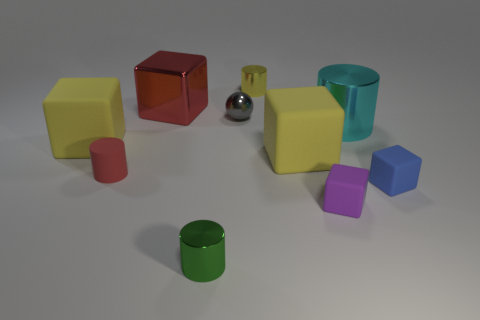Subtract all big metallic blocks. How many blocks are left? 4 Subtract all blue blocks. How many blocks are left? 4 Subtract all green blocks. Subtract all green cylinders. How many blocks are left? 5 Subtract all spheres. How many objects are left? 9 Add 6 small green things. How many small green things are left? 7 Add 4 large purple rubber spheres. How many large purple rubber spheres exist? 4 Subtract 1 yellow cylinders. How many objects are left? 9 Subtract all yellow shiny things. Subtract all purple things. How many objects are left? 8 